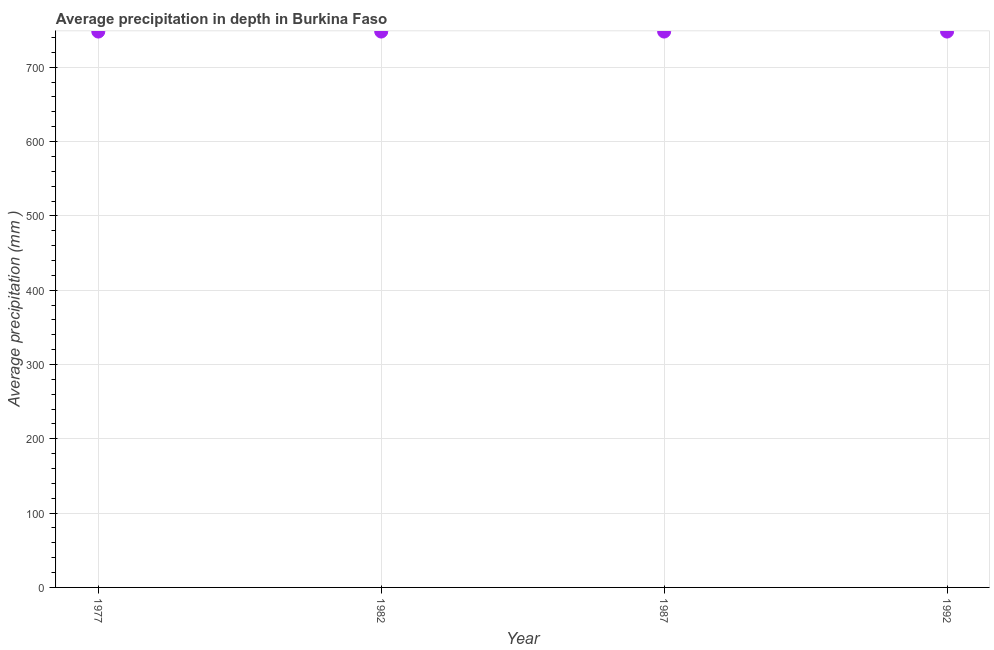What is the average precipitation in depth in 1992?
Offer a terse response. 748. Across all years, what is the maximum average precipitation in depth?
Your response must be concise. 748. Across all years, what is the minimum average precipitation in depth?
Your response must be concise. 748. In which year was the average precipitation in depth maximum?
Your answer should be very brief. 1977. In which year was the average precipitation in depth minimum?
Make the answer very short. 1977. What is the sum of the average precipitation in depth?
Your response must be concise. 2992. What is the difference between the average precipitation in depth in 1977 and 1982?
Make the answer very short. 0. What is the average average precipitation in depth per year?
Offer a very short reply. 748. What is the median average precipitation in depth?
Keep it short and to the point. 748. What is the ratio of the average precipitation in depth in 1977 to that in 1992?
Provide a short and direct response. 1. Is the difference between the average precipitation in depth in 1977 and 1982 greater than the difference between any two years?
Your answer should be compact. Yes. What is the difference between the highest and the second highest average precipitation in depth?
Your answer should be compact. 0. Is the sum of the average precipitation in depth in 1977 and 1992 greater than the maximum average precipitation in depth across all years?
Provide a succinct answer. Yes. In how many years, is the average precipitation in depth greater than the average average precipitation in depth taken over all years?
Your answer should be very brief. 0. Does the graph contain any zero values?
Keep it short and to the point. No. Does the graph contain grids?
Your answer should be compact. Yes. What is the title of the graph?
Make the answer very short. Average precipitation in depth in Burkina Faso. What is the label or title of the Y-axis?
Your answer should be compact. Average precipitation (mm ). What is the Average precipitation (mm ) in 1977?
Your response must be concise. 748. What is the Average precipitation (mm ) in 1982?
Make the answer very short. 748. What is the Average precipitation (mm ) in 1987?
Your response must be concise. 748. What is the Average precipitation (mm ) in 1992?
Keep it short and to the point. 748. What is the difference between the Average precipitation (mm ) in 1977 and 1982?
Your response must be concise. 0. What is the difference between the Average precipitation (mm ) in 1977 and 1987?
Ensure brevity in your answer.  0. What is the difference between the Average precipitation (mm ) in 1977 and 1992?
Give a very brief answer. 0. What is the ratio of the Average precipitation (mm ) in 1977 to that in 1982?
Your answer should be very brief. 1. What is the ratio of the Average precipitation (mm ) in 1982 to that in 1987?
Give a very brief answer. 1. What is the ratio of the Average precipitation (mm ) in 1987 to that in 1992?
Give a very brief answer. 1. 